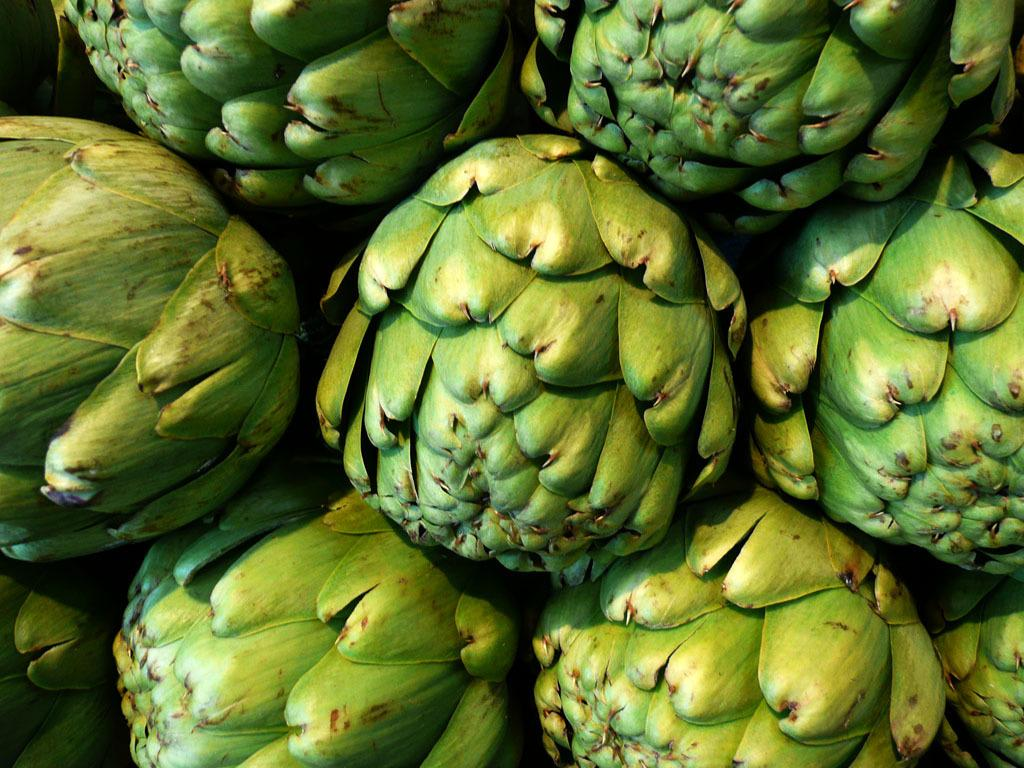What type of vegetable is present in the image? There are artichokes in the image. What type of jewel is being transported by the plane in the image? There is no plane or jewel present in the image; it only features artichokes. 